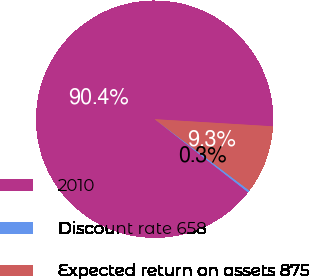Convert chart to OTSL. <chart><loc_0><loc_0><loc_500><loc_500><pie_chart><fcel>2010<fcel>Discount rate 658<fcel>Expected return on assets 875<nl><fcel>90.39%<fcel>0.3%<fcel>9.31%<nl></chart> 